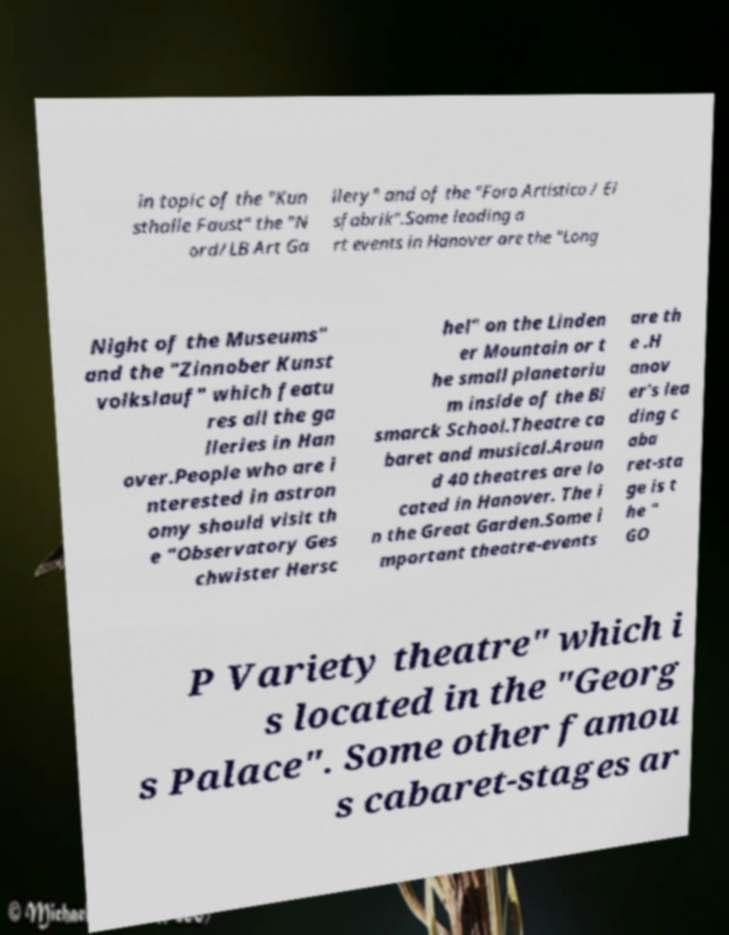I need the written content from this picture converted into text. Can you do that? in topic of the "Kun sthalle Faust" the "N ord/LB Art Ga llery" and of the "Foro Artistico / Ei sfabrik".Some leading a rt events in Hanover are the "Long Night of the Museums" and the "Zinnober Kunst volkslauf" which featu res all the ga lleries in Han over.People who are i nterested in astron omy should visit th e "Observatory Ges chwister Hersc hel" on the Linden er Mountain or t he small planetariu m inside of the Bi smarck School.Theatre ca baret and musical.Aroun d 40 theatres are lo cated in Hanover. The i n the Great Garden.Some i mportant theatre-events are th e .H anov er's lea ding c aba ret-sta ge is t he " GO P Variety theatre" which i s located in the "Georg s Palace". Some other famou s cabaret-stages ar 